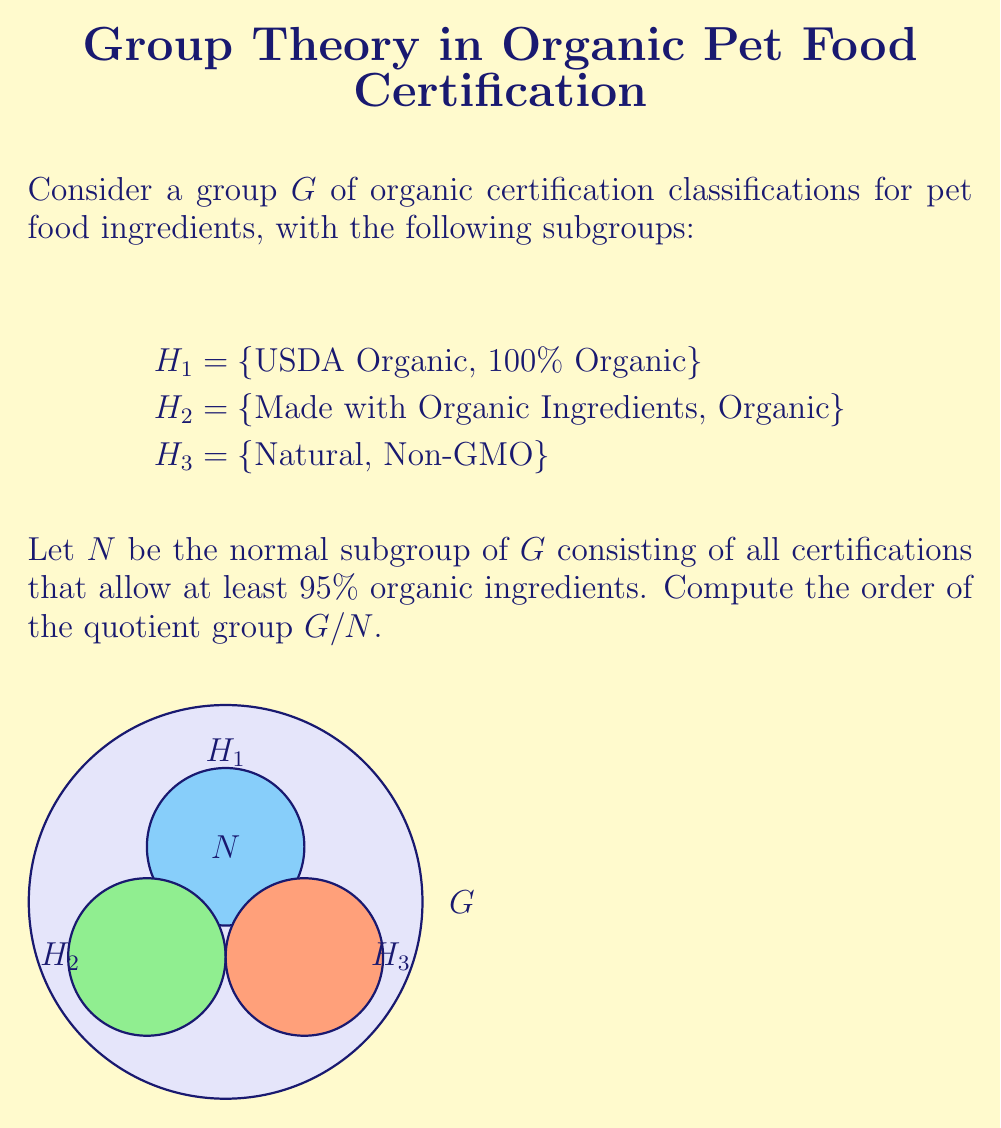Solve this math problem. To compute the order of the quotient group $G/N$, we need to follow these steps:

1) First, identify the elements of the normal subgroup $N$:
   $N$ = {USDA Organic, 100% Organic, Organic}
   These certifications allow at least 95% organic ingredients.

2) The order of $G/N$ is equal to the number of distinct cosets of $N$ in $G$. This is given by the formula:

   $|G/N| = |G| / |N|$

3) We need to determine $|G|$ and $|N|$:
   
   $|N| = 3$ (as counted in step 1)
   
   To find $|G|$, we need to count all unique elements:
   $G$ = {USDA Organic, 100% Organic, Organic, Made with Organic Ingredients, Natural, Non-GMO}
   $|G| = 6$

4) Now we can compute:

   $|G/N| = |G| / |N| = 6 / 3 = 2$

Therefore, the quotient group $G/N$ has order 2.

This means there are two cosets:
- The coset containing $N$ itself
- The coset containing the elements not in $N$ (Made with Organic Ingredients, Natural, Non-GMO)
Answer: $|G/N| = 2$ 